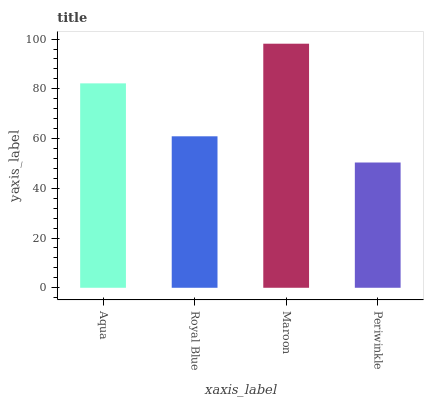Is Periwinkle the minimum?
Answer yes or no. Yes. Is Maroon the maximum?
Answer yes or no. Yes. Is Royal Blue the minimum?
Answer yes or no. No. Is Royal Blue the maximum?
Answer yes or no. No. Is Aqua greater than Royal Blue?
Answer yes or no. Yes. Is Royal Blue less than Aqua?
Answer yes or no. Yes. Is Royal Blue greater than Aqua?
Answer yes or no. No. Is Aqua less than Royal Blue?
Answer yes or no. No. Is Aqua the high median?
Answer yes or no. Yes. Is Royal Blue the low median?
Answer yes or no. Yes. Is Periwinkle the high median?
Answer yes or no. No. Is Periwinkle the low median?
Answer yes or no. No. 